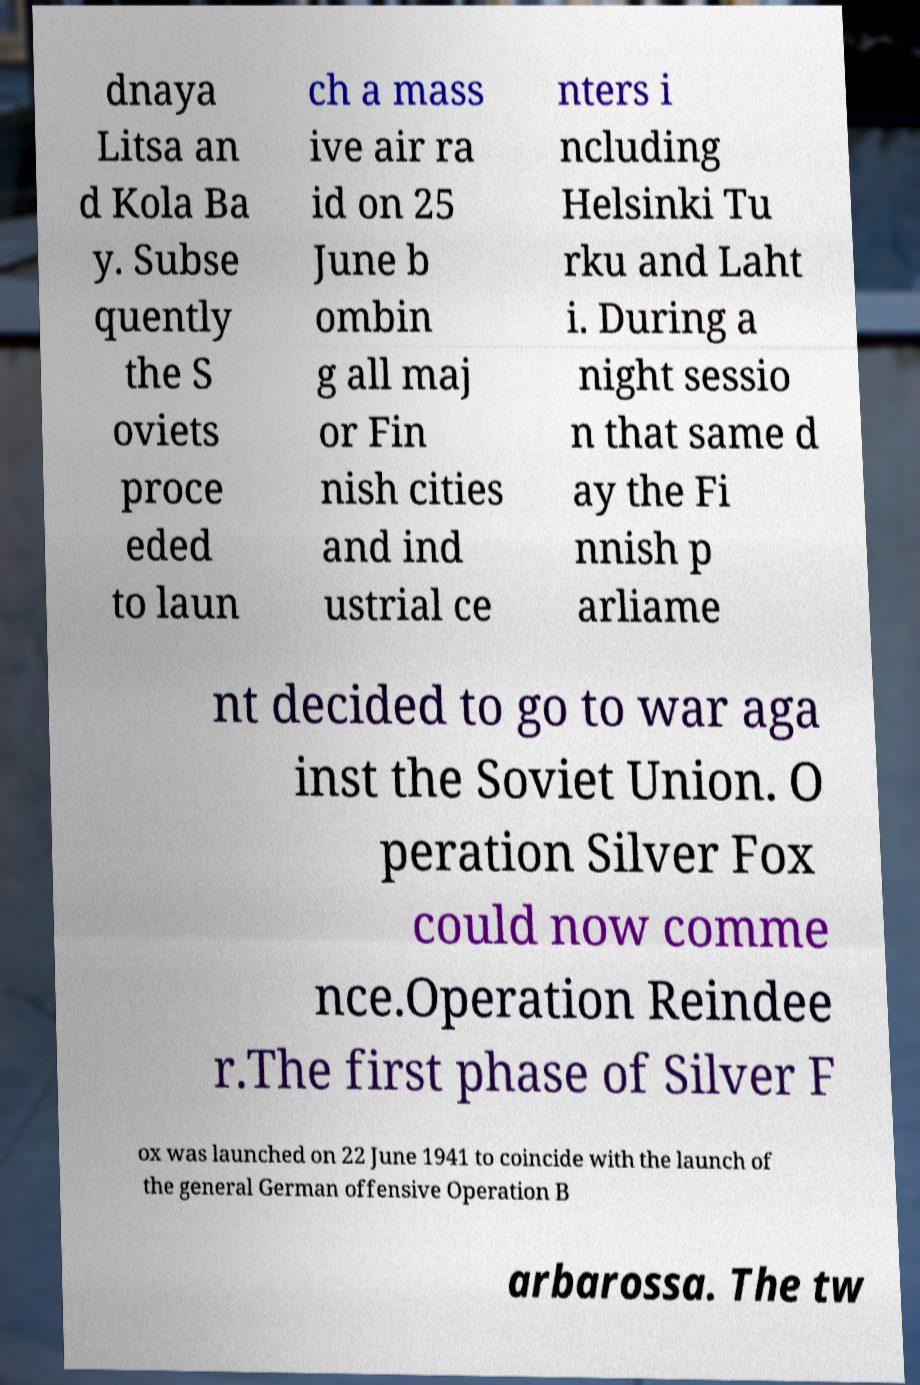There's text embedded in this image that I need extracted. Can you transcribe it verbatim? dnaya Litsa an d Kola Ba y. Subse quently the S oviets proce eded to laun ch a mass ive air ra id on 25 June b ombin g all maj or Fin nish cities and ind ustrial ce nters i ncluding Helsinki Tu rku and Laht i. During a night sessio n that same d ay the Fi nnish p arliame nt decided to go to war aga inst the Soviet Union. O peration Silver Fox could now comme nce.Operation Reindee r.The first phase of Silver F ox was launched on 22 June 1941 to coincide with the launch of the general German offensive Operation B arbarossa. The tw 